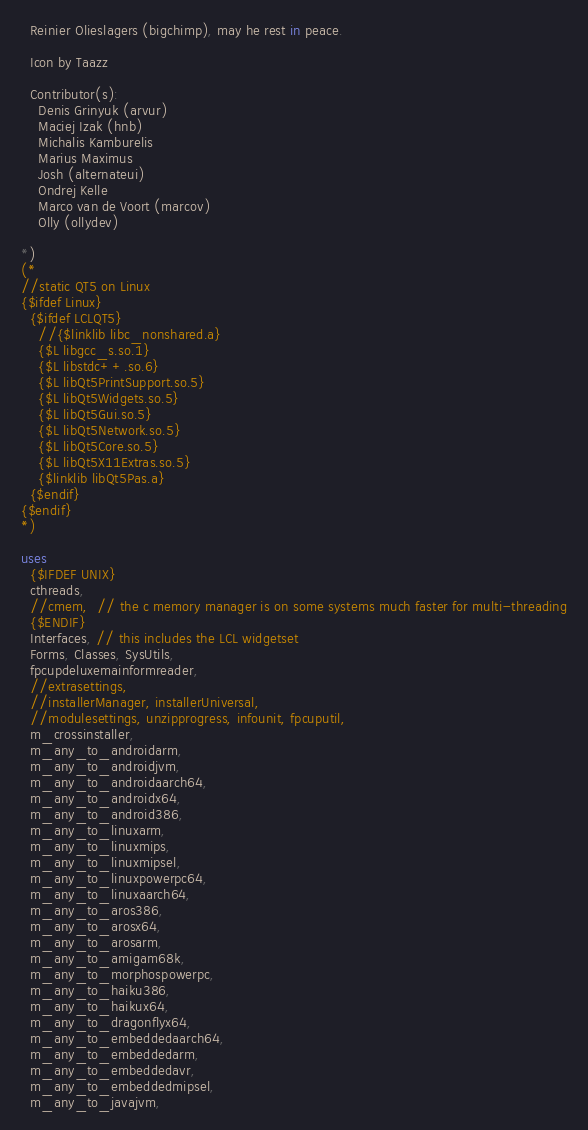Convert code to text. <code><loc_0><loc_0><loc_500><loc_500><_Pascal_>  Reinier Olieslagers (bigchimp), may he rest in peace.

  Icon by Taazz

  Contributor(s):
    Denis Grinyuk (arvur)
    Maciej Izak (hnb)
    Michalis Kamburelis
    Marius Maximus
    Josh (alternateui)
    Ondrej Kelle
    Marco van de Voort (marcov)
    Olly (ollydev)

*)
(*
//static QT5 on Linux
{$ifdef Linux}
  {$ifdef LCLQT5}
    //{$linklib libc_nonshared.a}
    {$L libgcc_s.so.1}
    {$L libstdc++.so.6}
    {$L libQt5PrintSupport.so.5}
    {$L libQt5Widgets.so.5}
    {$L libQt5Gui.so.5}
    {$L libQt5Network.so.5}
    {$L libQt5Core.so.5}
    {$L libQt5X11Extras.so.5}
    {$linklib libQt5Pas.a}
  {$endif}
{$endif}
*)

uses
  {$IFDEF UNIX}
  cthreads,
  //cmem,  // the c memory manager is on some systems much faster for multi-threading
  {$ENDIF}
  Interfaces, // this includes the LCL widgetset
  Forms, Classes, SysUtils,
  fpcupdeluxemainformreader,
  //extrasettings,
  //installerManager, installerUniversal,
  //modulesettings, unzipprogress, infounit, fpcuputil,
  m_crossinstaller,
  m_any_to_androidarm,
  m_any_to_androidjvm,
  m_any_to_androidaarch64,
  m_any_to_androidx64,
  m_any_to_android386,
  m_any_to_linuxarm,
  m_any_to_linuxmips,
  m_any_to_linuxmipsel,
  m_any_to_linuxpowerpc64,
  m_any_to_linuxaarch64,
  m_any_to_aros386,
  m_any_to_arosx64,
  m_any_to_arosarm,
  m_any_to_amigam68k,
  m_any_to_morphospowerpc,
  m_any_to_haiku386,
  m_any_to_haikux64,
  m_any_to_dragonflyx64,
  m_any_to_embeddedaarch64,
  m_any_to_embeddedarm,
  m_any_to_embeddedavr,
  m_any_to_embeddedmipsel,
  m_any_to_javajvm,</code> 